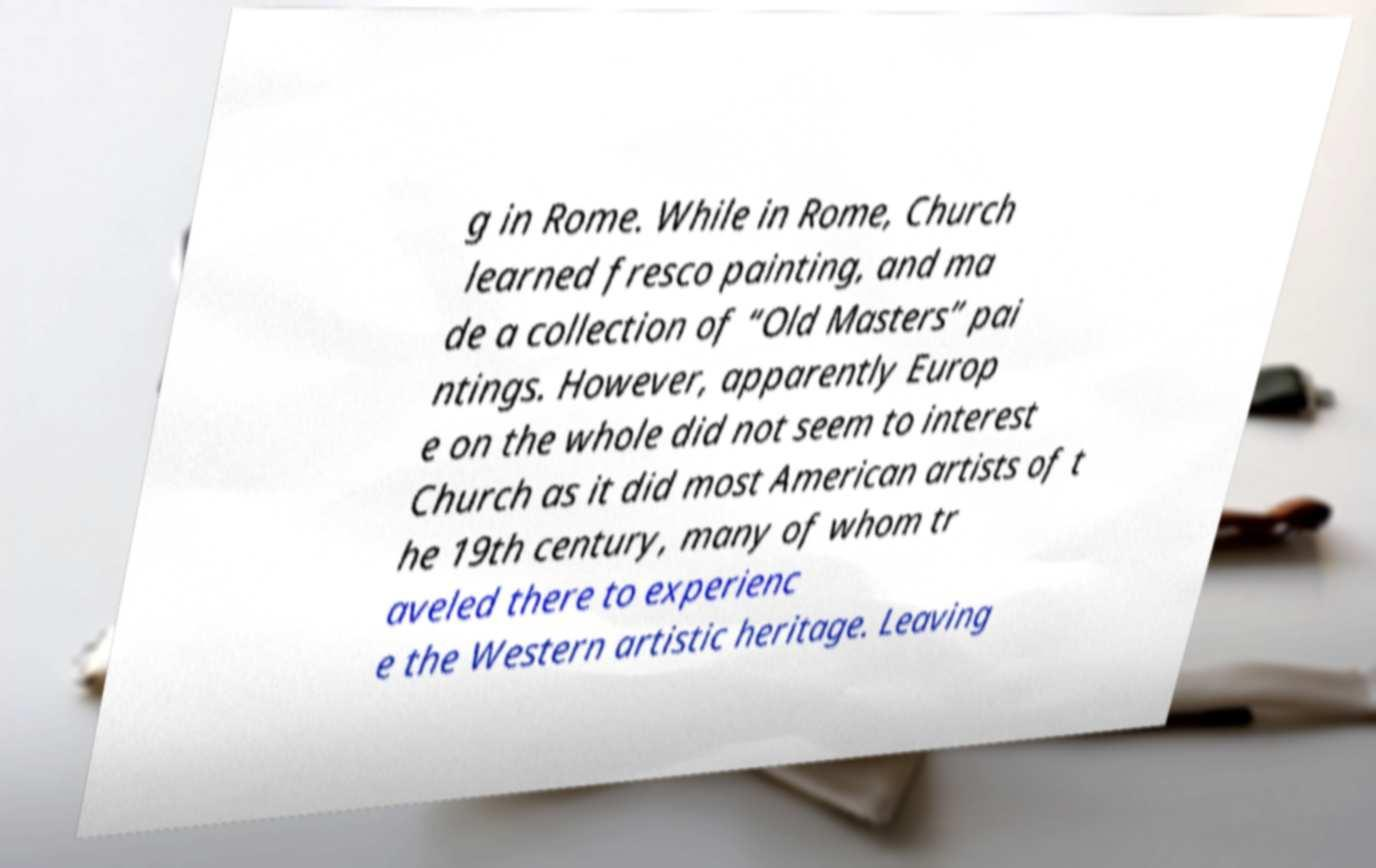For documentation purposes, I need the text within this image transcribed. Could you provide that? g in Rome. While in Rome, Church learned fresco painting, and ma de a collection of “Old Masters” pai ntings. However, apparently Europ e on the whole did not seem to interest Church as it did most American artists of t he 19th century, many of whom tr aveled there to experienc e the Western artistic heritage. Leaving 